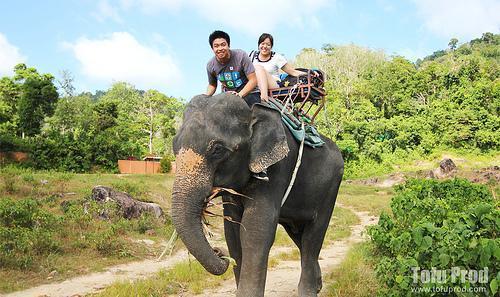How many people are riding the elephant?
Give a very brief answer. 2. 